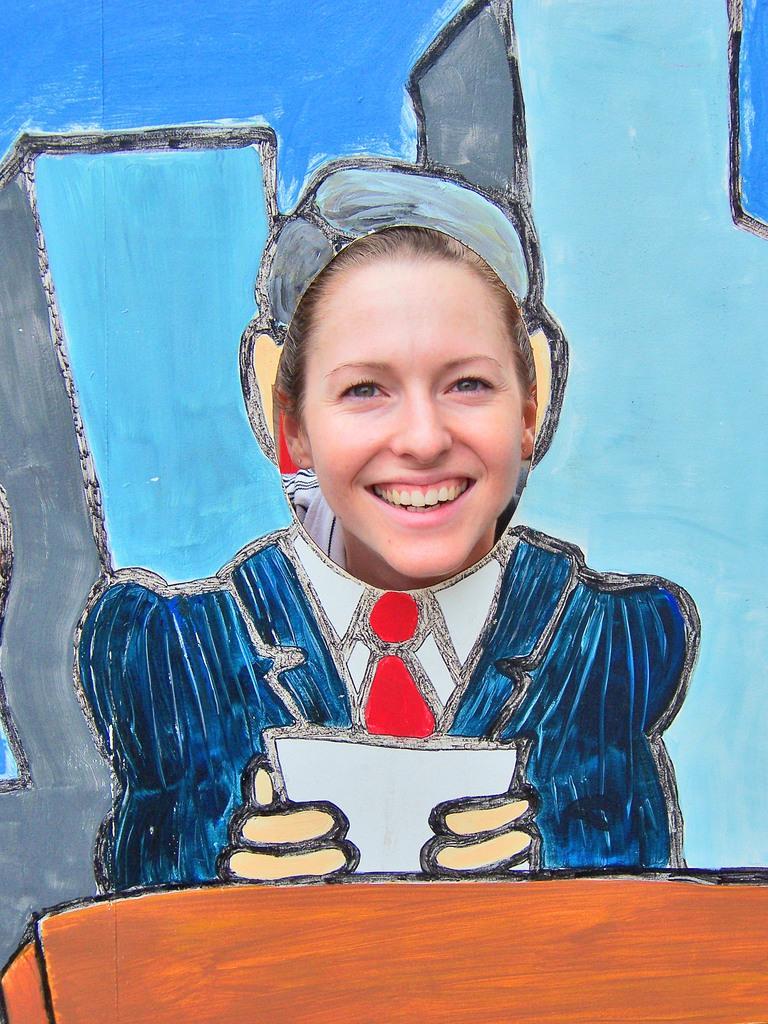Can you describe this image briefly? This is a person, this is paper. 